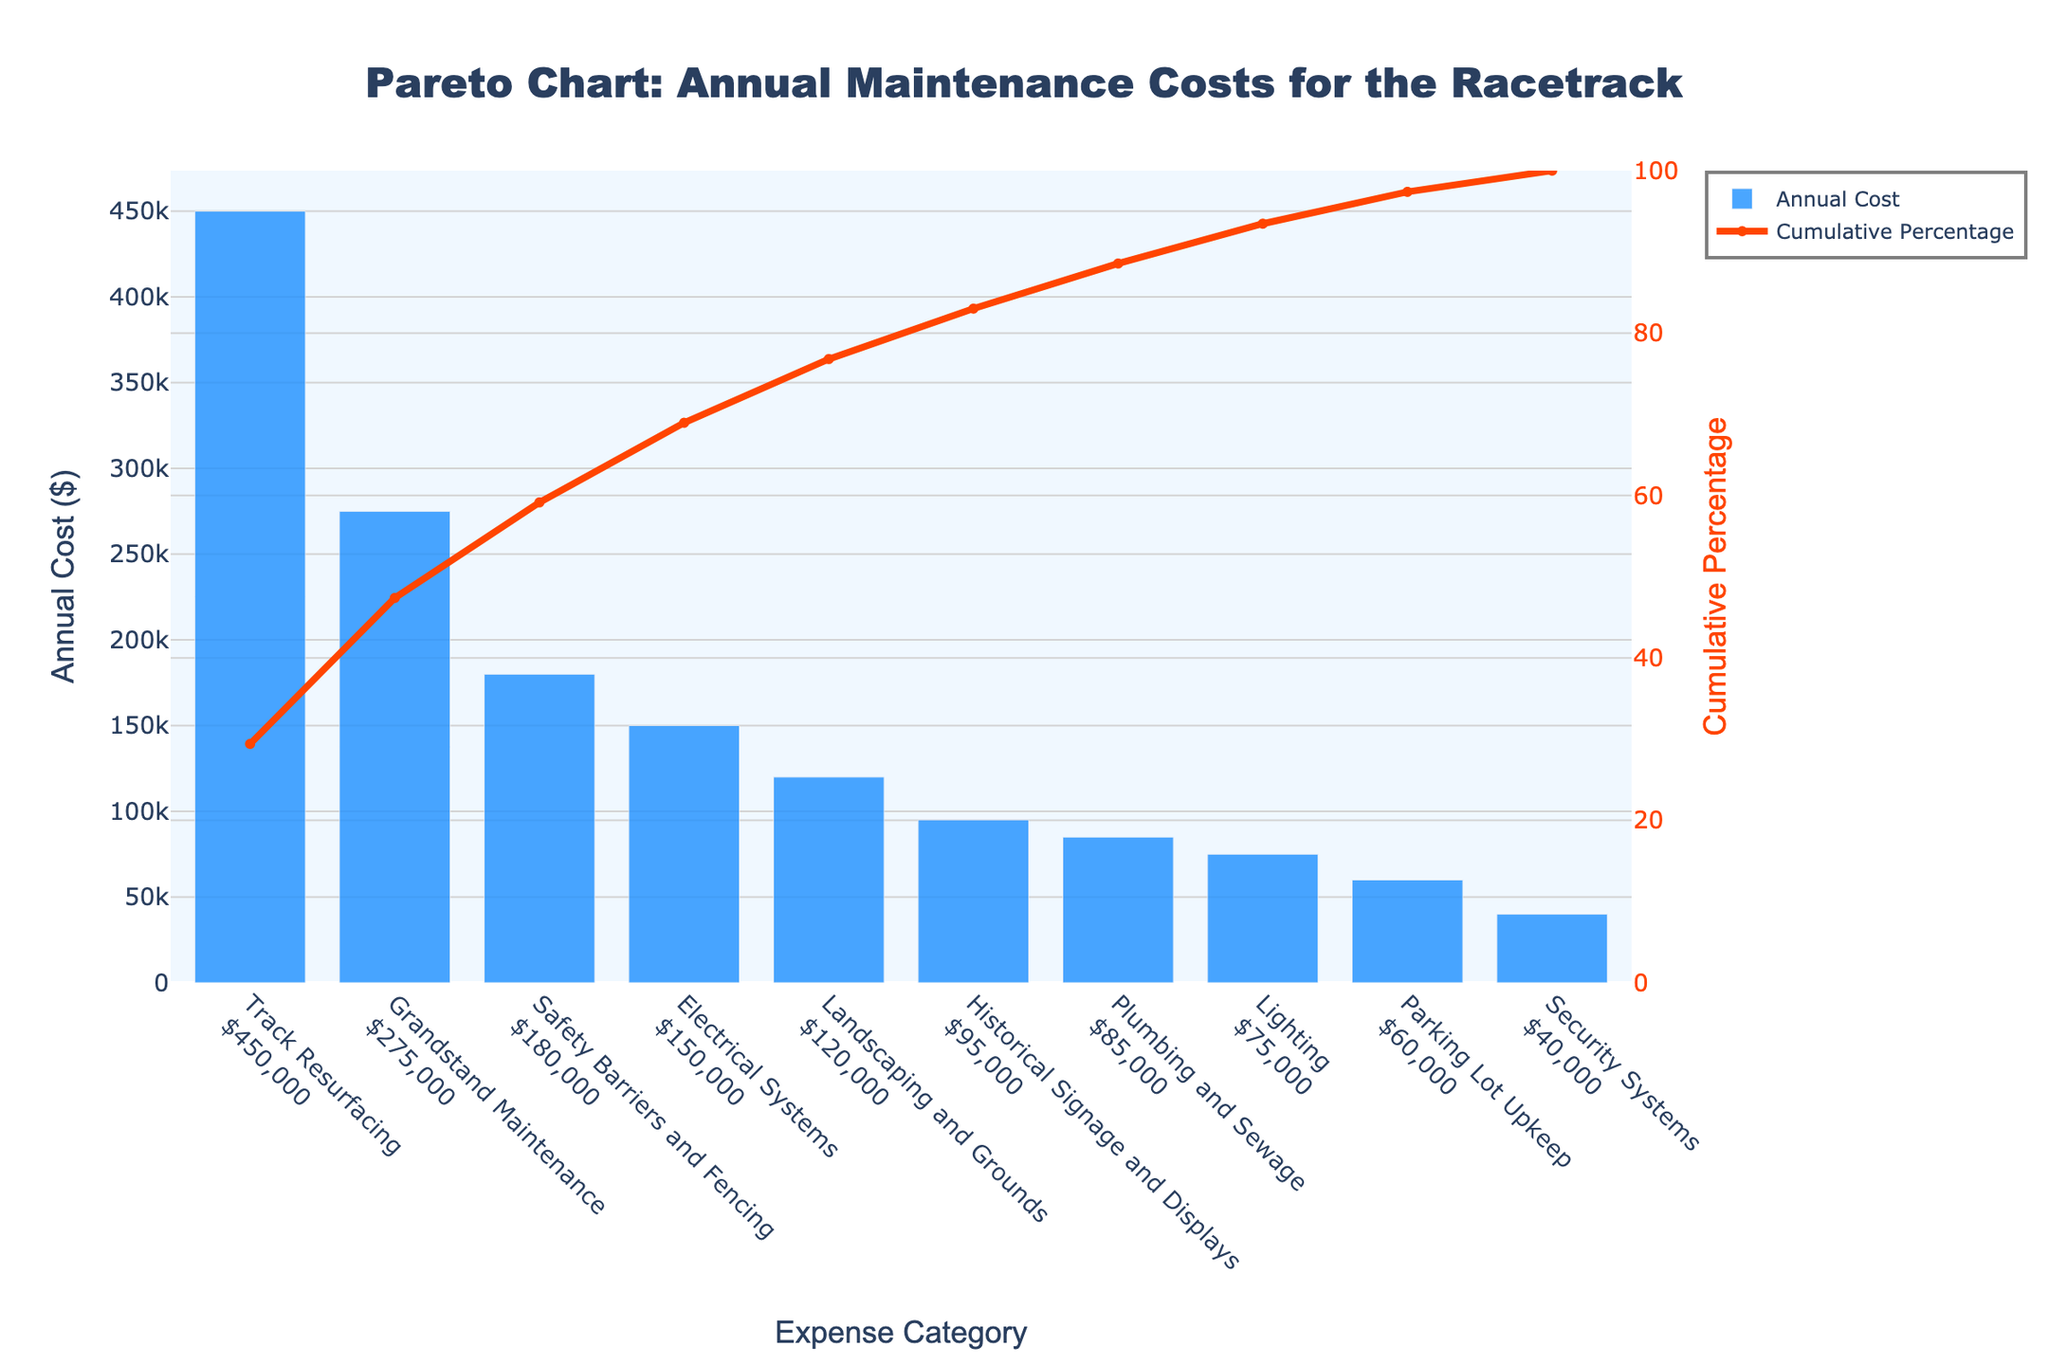How many expense categories are shown in the chart? The Pareto chart contains a bar for each expense category, so count the number of bars.
Answer: 10 What is the highest annual cost category? The highest annual cost category will have the tallest bar in the Pareto chart.
Answer: Track Resurfacing What is the cumulative percentage after Historical Signage and Displays? The cumulative percentage line on the chart will show the value at the end of the Historical Signage and Displays category.
Answer: 85% How much more does Track Resurfacing cost compared to Landscaping and Grounds? Subtract the annual cost of Landscaping and Grounds from the annual cost of Track Resurfacing.
Answer: $330,000 What is the total annual maintenance cost for the first three categories? Add the annual costs of Track Resurfacing, Grandstand Maintenance, and Safety Barriers and Fencing.
Answer: $905,000 Which category costs less than Plumbing and Sewage but more than Lighting? Identify the categories by comparing the bar heights for the specified range.
Answer: Historical Signage and Displays At what point does the cumulative percentage reach approximately 50%? Check the point on the cumulative percentage line where it is closest to 50%.
Answer: After Grandstand Maintenance What is the combined annual cost of Electrical Systems and Security Systems? Add the annual costs of Electrical Systems and Security Systems.
Answer: $190,000 How does the cost of Parking Lot Upkeep compare to Security Systems? Compare the bar heights representing the annual costs of Parking Lot Upkeep and Security Systems.
Answer: Higher What percentage of the total cost does Track Resurfacing contribute? Divide the annual cost of Track Resurfacing by the total annual cost and multiply by 100 for percentage.
Answer: 31.03% 